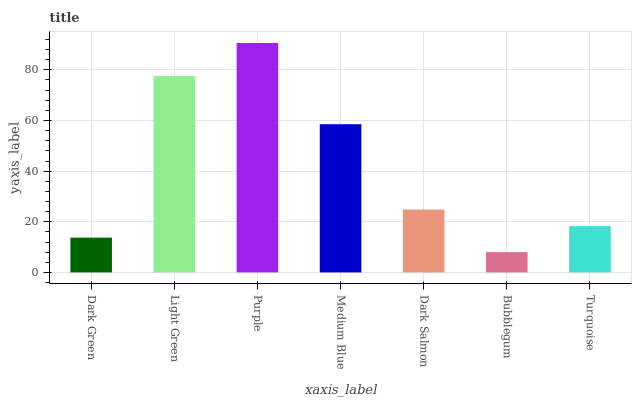Is Bubblegum the minimum?
Answer yes or no. Yes. Is Purple the maximum?
Answer yes or no. Yes. Is Light Green the minimum?
Answer yes or no. No. Is Light Green the maximum?
Answer yes or no. No. Is Light Green greater than Dark Green?
Answer yes or no. Yes. Is Dark Green less than Light Green?
Answer yes or no. Yes. Is Dark Green greater than Light Green?
Answer yes or no. No. Is Light Green less than Dark Green?
Answer yes or no. No. Is Dark Salmon the high median?
Answer yes or no. Yes. Is Dark Salmon the low median?
Answer yes or no. Yes. Is Bubblegum the high median?
Answer yes or no. No. Is Light Green the low median?
Answer yes or no. No. 